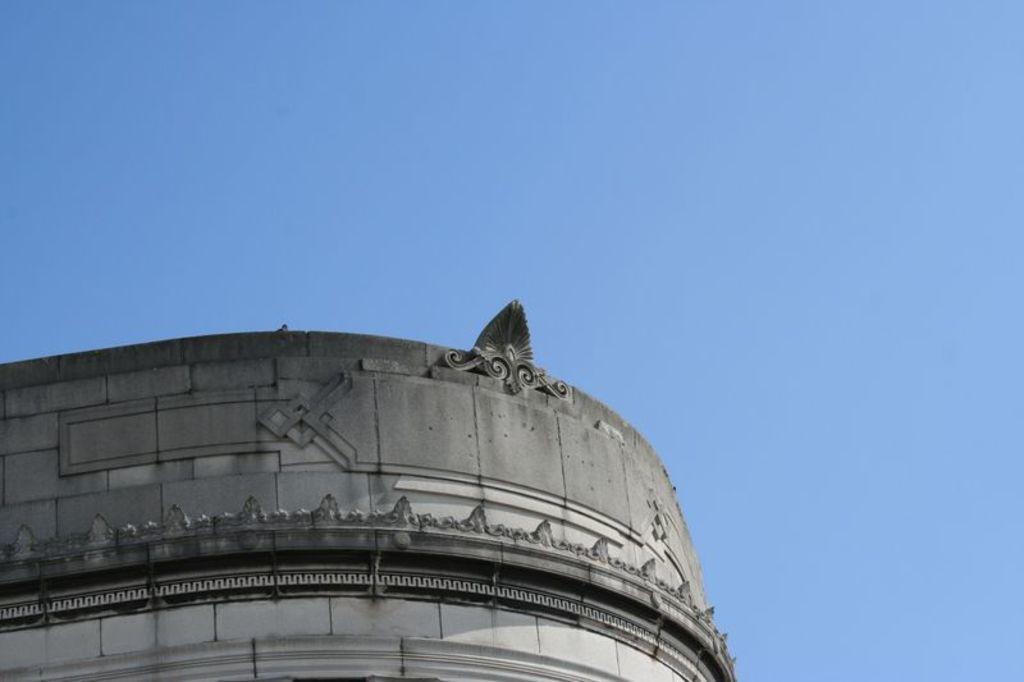Could you give a brief overview of what you see in this image? In this picture there is a building and there is a floral design on the wall. At the top there is sky. 